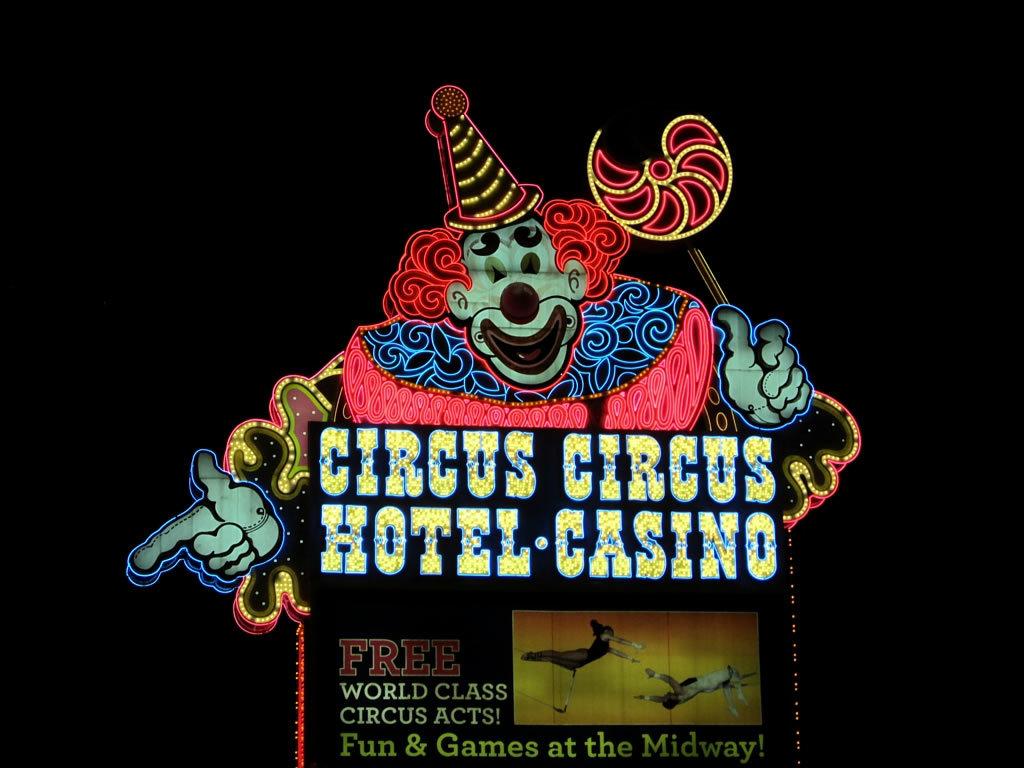How much does it cost to get into the circus acts?
Provide a short and direct response. Free. This has a hotel and a what?
Your response must be concise. Casino. 